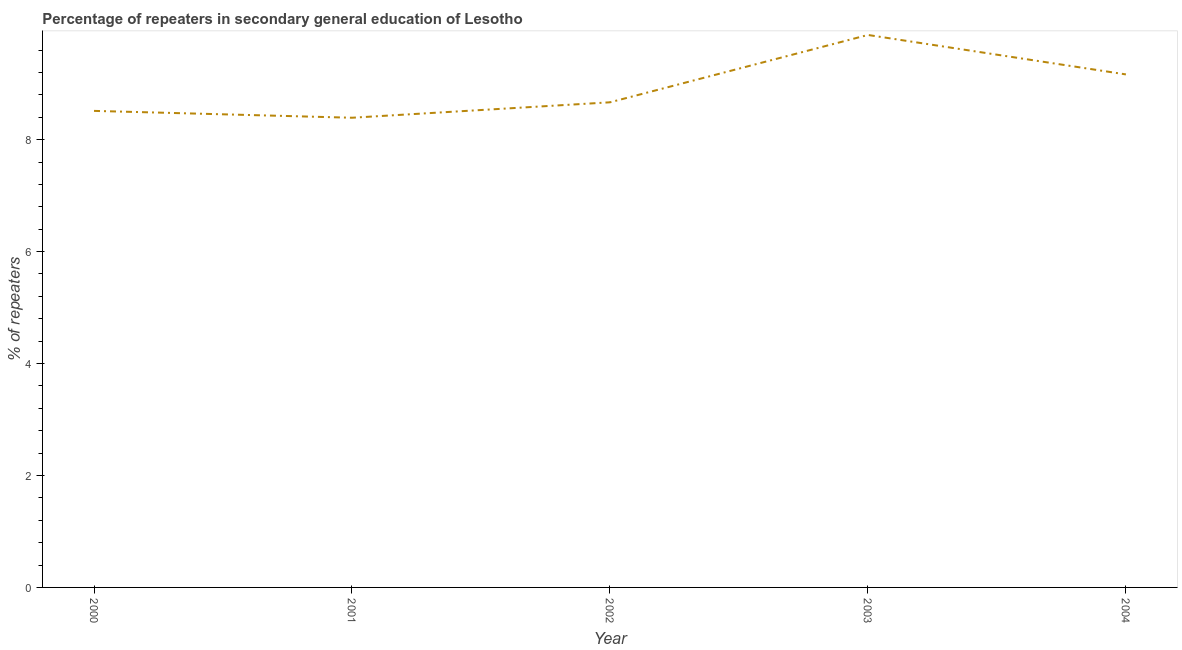What is the percentage of repeaters in 2003?
Ensure brevity in your answer.  9.87. Across all years, what is the maximum percentage of repeaters?
Offer a very short reply. 9.87. Across all years, what is the minimum percentage of repeaters?
Provide a succinct answer. 8.39. What is the sum of the percentage of repeaters?
Provide a succinct answer. 44.6. What is the difference between the percentage of repeaters in 2002 and 2003?
Keep it short and to the point. -1.2. What is the average percentage of repeaters per year?
Your response must be concise. 8.92. What is the median percentage of repeaters?
Offer a very short reply. 8.67. What is the ratio of the percentage of repeaters in 2001 to that in 2003?
Give a very brief answer. 0.85. What is the difference between the highest and the second highest percentage of repeaters?
Give a very brief answer. 0.7. What is the difference between the highest and the lowest percentage of repeaters?
Provide a short and direct response. 1.48. In how many years, is the percentage of repeaters greater than the average percentage of repeaters taken over all years?
Your response must be concise. 2. Does the percentage of repeaters monotonically increase over the years?
Your answer should be compact. No. How many years are there in the graph?
Ensure brevity in your answer.  5. Are the values on the major ticks of Y-axis written in scientific E-notation?
Ensure brevity in your answer.  No. Does the graph contain any zero values?
Your response must be concise. No. What is the title of the graph?
Offer a very short reply. Percentage of repeaters in secondary general education of Lesotho. What is the label or title of the Y-axis?
Provide a short and direct response. % of repeaters. What is the % of repeaters of 2000?
Keep it short and to the point. 8.51. What is the % of repeaters in 2001?
Keep it short and to the point. 8.39. What is the % of repeaters of 2002?
Your answer should be very brief. 8.67. What is the % of repeaters of 2003?
Your answer should be compact. 9.87. What is the % of repeaters of 2004?
Offer a terse response. 9.16. What is the difference between the % of repeaters in 2000 and 2001?
Offer a very short reply. 0.12. What is the difference between the % of repeaters in 2000 and 2002?
Make the answer very short. -0.15. What is the difference between the % of repeaters in 2000 and 2003?
Your response must be concise. -1.36. What is the difference between the % of repeaters in 2000 and 2004?
Give a very brief answer. -0.65. What is the difference between the % of repeaters in 2001 and 2002?
Provide a short and direct response. -0.28. What is the difference between the % of repeaters in 2001 and 2003?
Ensure brevity in your answer.  -1.48. What is the difference between the % of repeaters in 2001 and 2004?
Give a very brief answer. -0.77. What is the difference between the % of repeaters in 2002 and 2003?
Provide a short and direct response. -1.2. What is the difference between the % of repeaters in 2002 and 2004?
Provide a succinct answer. -0.5. What is the difference between the % of repeaters in 2003 and 2004?
Your answer should be very brief. 0.7. What is the ratio of the % of repeaters in 2000 to that in 2003?
Provide a short and direct response. 0.86. What is the ratio of the % of repeaters in 2000 to that in 2004?
Offer a terse response. 0.93. What is the ratio of the % of repeaters in 2001 to that in 2002?
Offer a very short reply. 0.97. What is the ratio of the % of repeaters in 2001 to that in 2004?
Your answer should be very brief. 0.92. What is the ratio of the % of repeaters in 2002 to that in 2003?
Ensure brevity in your answer.  0.88. What is the ratio of the % of repeaters in 2002 to that in 2004?
Give a very brief answer. 0.95. What is the ratio of the % of repeaters in 2003 to that in 2004?
Give a very brief answer. 1.08. 